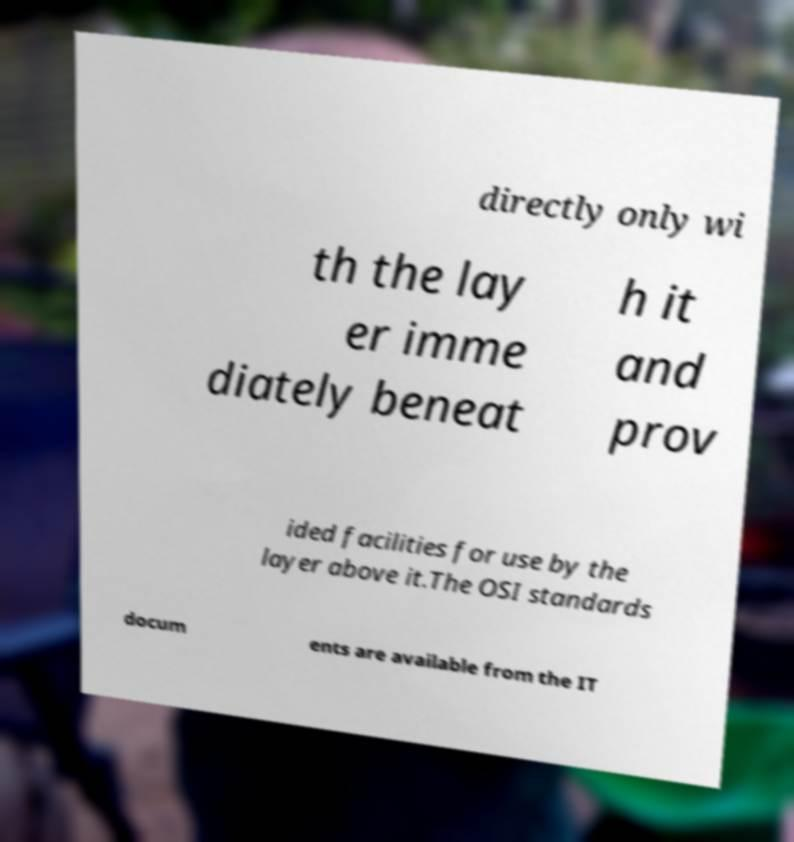What messages or text are displayed in this image? I need them in a readable, typed format. directly only wi th the lay er imme diately beneat h it and prov ided facilities for use by the layer above it.The OSI standards docum ents are available from the IT 